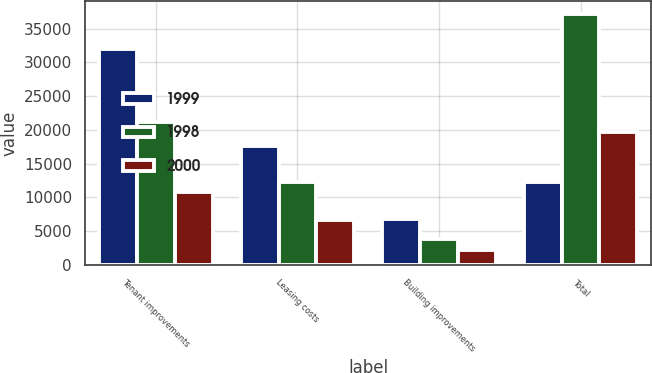Convert chart to OTSL. <chart><loc_0><loc_0><loc_500><loc_500><stacked_bar_chart><ecel><fcel>Tenant improvements<fcel>Leasing costs<fcel>Building improvements<fcel>Total<nl><fcel>1999<fcel>31955<fcel>17530<fcel>6804<fcel>12326<nl><fcel>1998<fcel>21144<fcel>12326<fcel>3751<fcel>37221<nl><fcel>2000<fcel>10785<fcel>6655<fcel>2206<fcel>19646<nl></chart> 